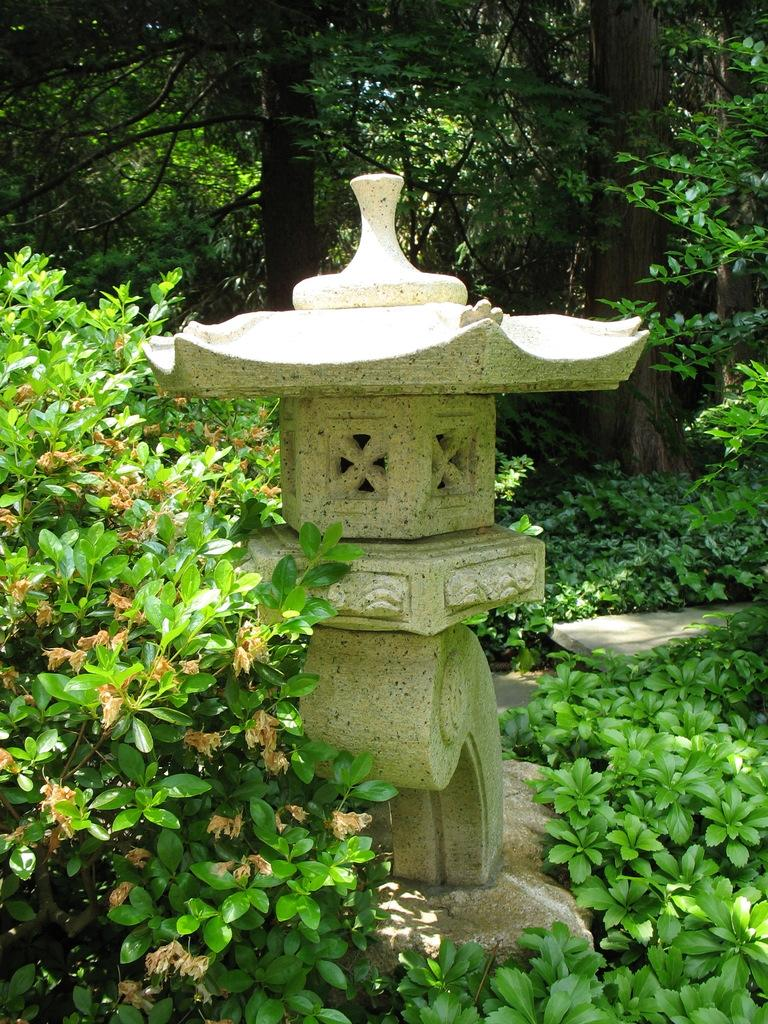What is the main subject of the image? There is a statue in the image. How is the statue positioned in the image? The statue is placed on the ground. What can be seen in the background of the image? There is a group of trees and plants in the background of the image. What type of grass is growing on the statue in the image? There is no grass growing on the statue in the image. What is the monetary value of the statue in the image? The value of the statue cannot be determined from the image alone. 